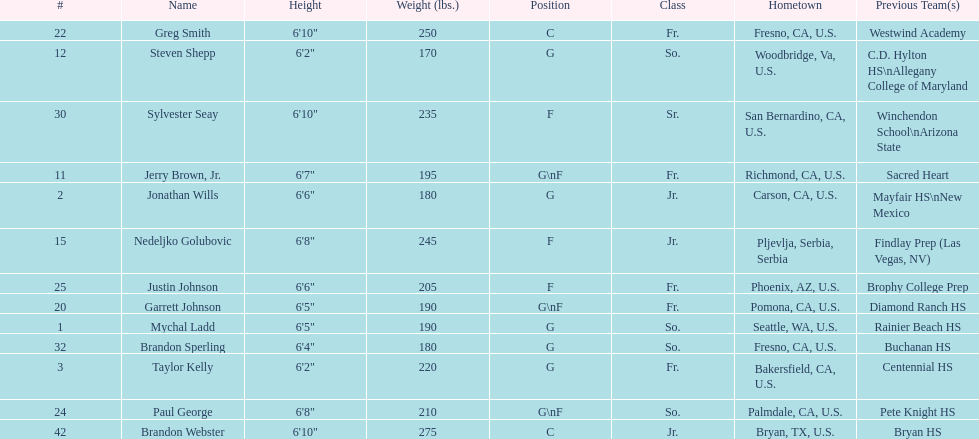Who is the next heaviest player after nedelijko golubovic? Sylvester Seay. 